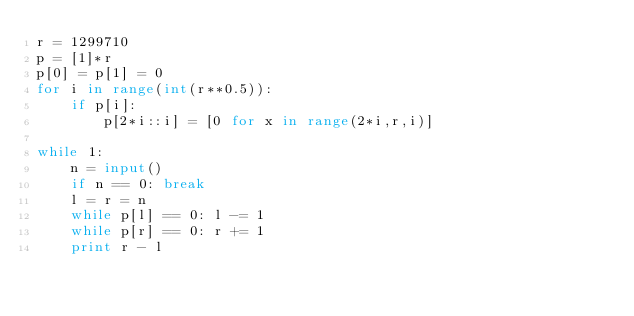<code> <loc_0><loc_0><loc_500><loc_500><_Python_>r = 1299710
p = [1]*r
p[0] = p[1] = 0
for i in range(int(r**0.5)):
	if p[i]:
		p[2*i::i] = [0 for x in range(2*i,r,i)]

while 1:
	n = input()
	if n == 0: break
	l = r = n
	while p[l] == 0: l -= 1
	while p[r] == 0: r += 1
	print r - l</code> 